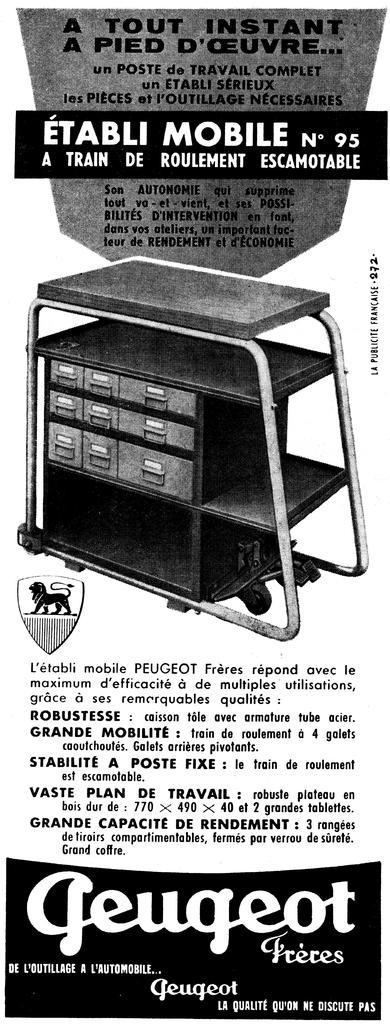<image>
Describe the image concisely. Poster that says "geugeot Pieces" in black on the bottom. 